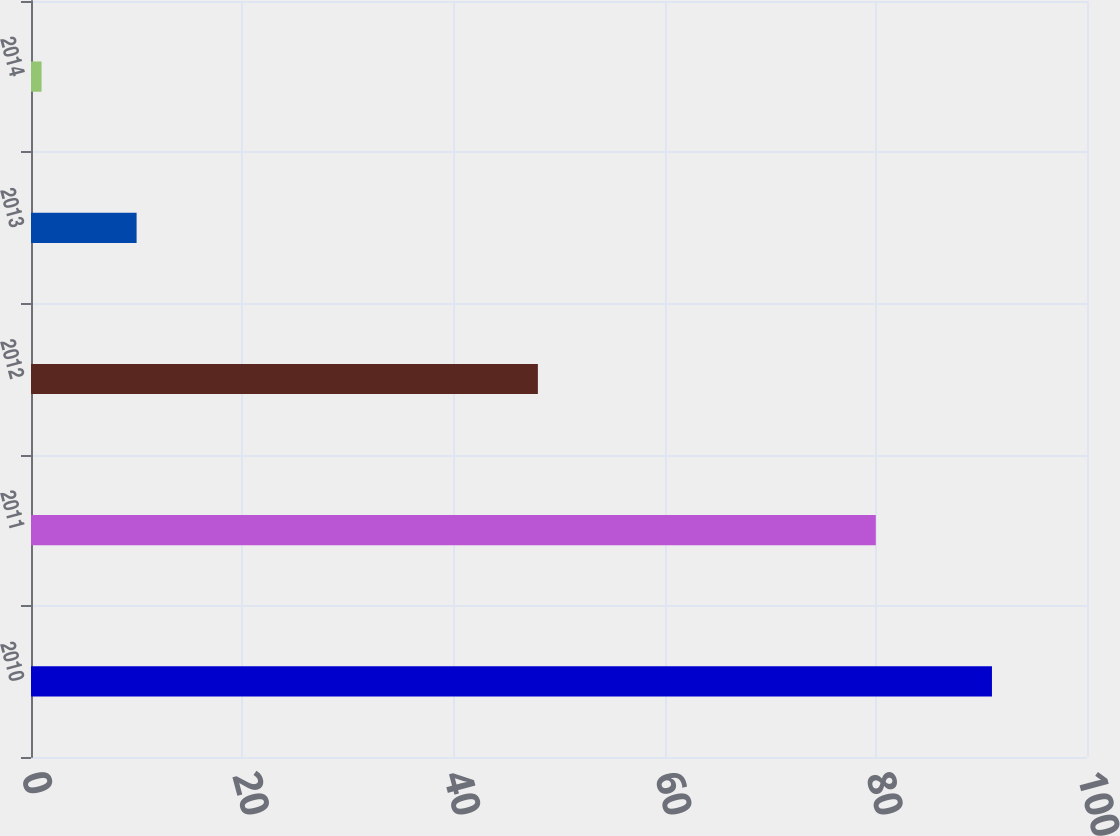Convert chart. <chart><loc_0><loc_0><loc_500><loc_500><bar_chart><fcel>2010<fcel>2011<fcel>2012<fcel>2013<fcel>2014<nl><fcel>91<fcel>80<fcel>48<fcel>10<fcel>1<nl></chart> 